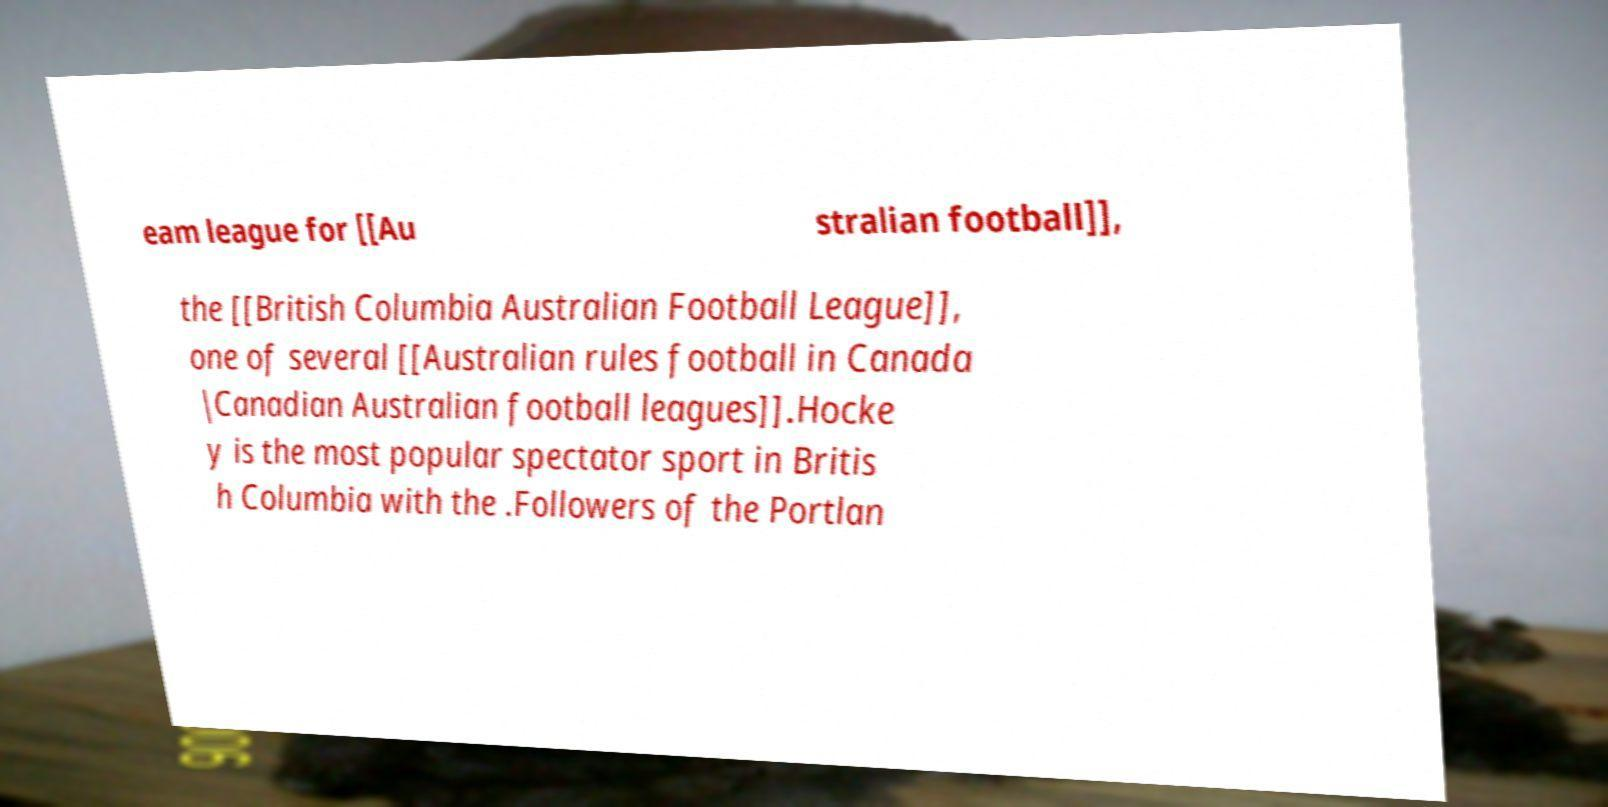Could you assist in decoding the text presented in this image and type it out clearly? eam league for [[Au stralian football]], the [[British Columbia Australian Football League]], one of several [[Australian rules football in Canada |Canadian Australian football leagues]].Hocke y is the most popular spectator sport in Britis h Columbia with the .Followers of the Portlan 